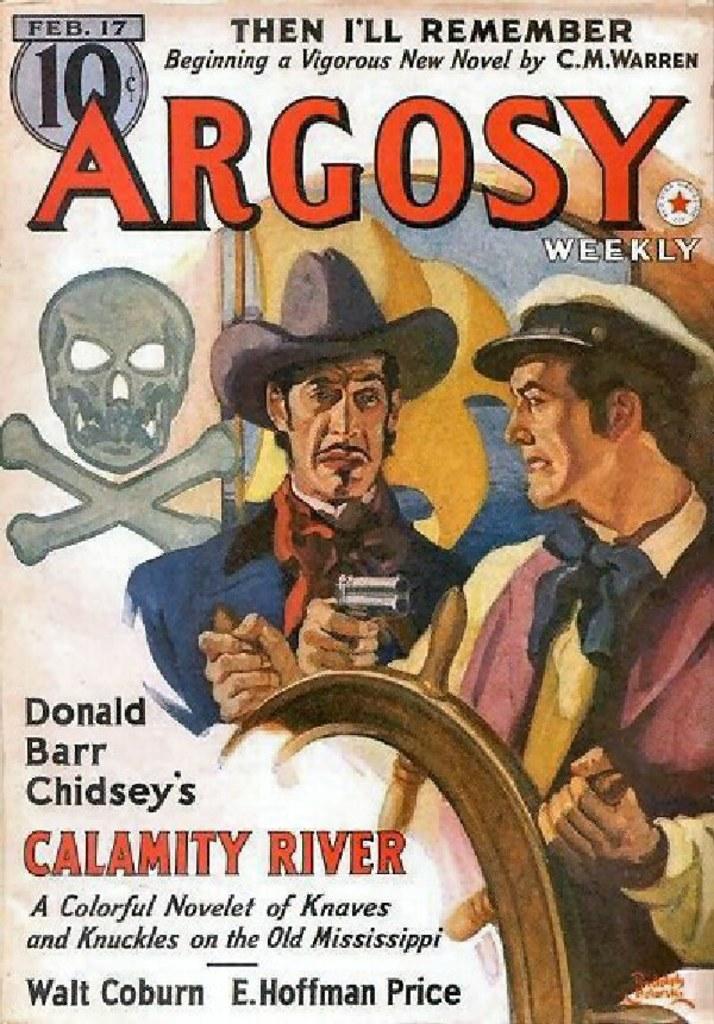Can you describe this image briefly? This is an article. This is a painting. In this picture we can see two persons wearing hats and holding a wheel. At the top and bottom of the image we can see the text. 